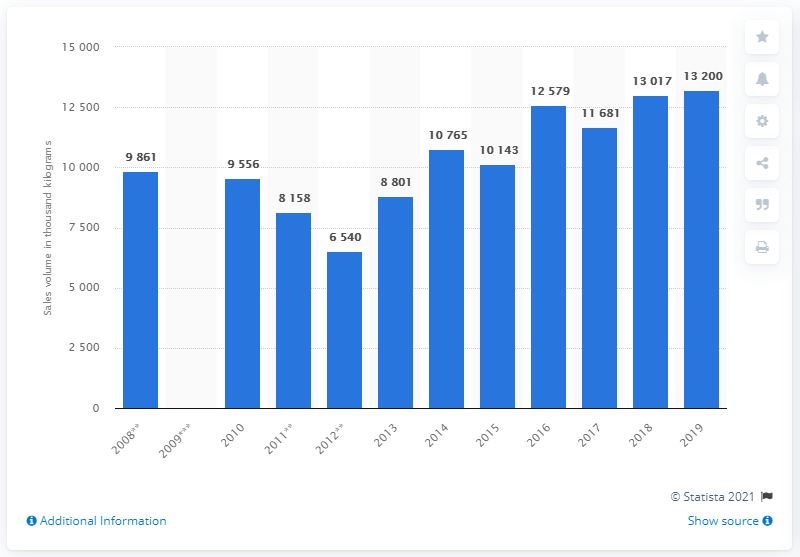Mention a couple of crucial points in this snapshot. In 2019, the sales volume of throat pastilles and cough drops was 13,200. 